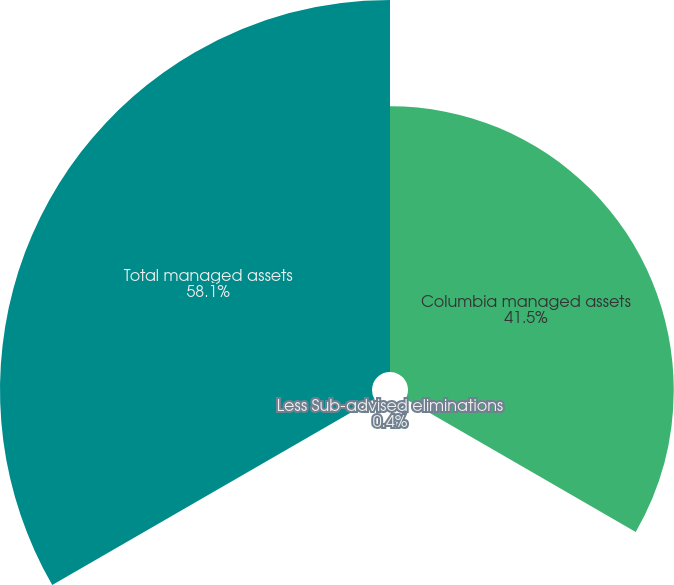Convert chart. <chart><loc_0><loc_0><loc_500><loc_500><pie_chart><fcel>Columbia managed assets<fcel>Less Sub-advised eliminations<fcel>Total managed assets<nl><fcel>41.5%<fcel>0.4%<fcel>58.09%<nl></chart> 